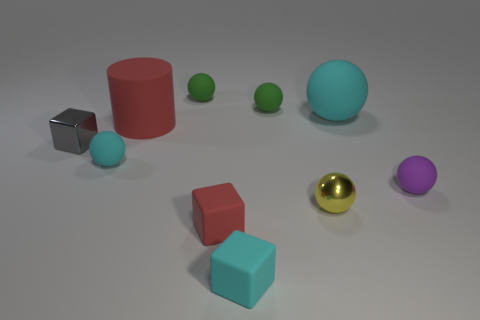Are there fewer green spheres that are in front of the purple matte ball than red cylinders in front of the large cylinder?
Your response must be concise. No. There is a small cyan matte thing that is behind the small shiny ball; is its shape the same as the small object that is right of the big cyan rubber ball?
Keep it short and to the point. Yes. What shape is the shiny thing that is in front of the cube behind the red matte block?
Your answer should be compact. Sphere. The matte cube that is the same color as the large matte cylinder is what size?
Keep it short and to the point. Small. Are there any spheres that have the same material as the small gray thing?
Your answer should be very brief. Yes. What is the red object in front of the metallic ball made of?
Offer a very short reply. Rubber. What is the cyan cube made of?
Keep it short and to the point. Rubber. Does the green thing that is right of the small red rubber thing have the same material as the small yellow sphere?
Give a very brief answer. No. Are there fewer cyan spheres that are left of the gray metal cube than big blue matte cylinders?
Make the answer very short. No. There is a rubber ball that is the same size as the cylinder; what color is it?
Your answer should be very brief. Cyan. 